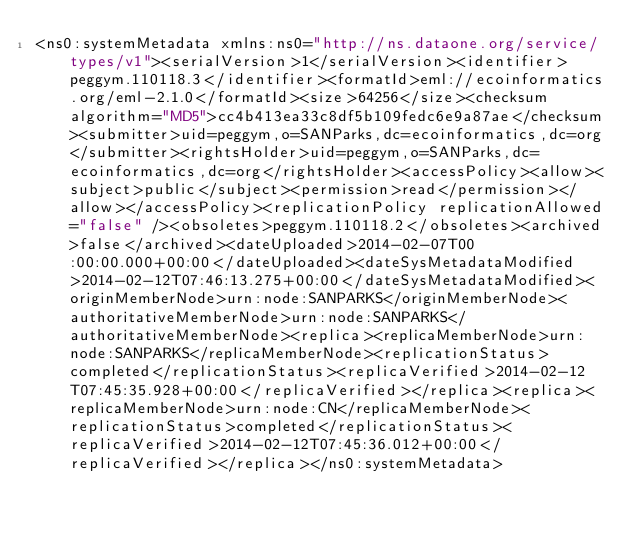<code> <loc_0><loc_0><loc_500><loc_500><_XML_><ns0:systemMetadata xmlns:ns0="http://ns.dataone.org/service/types/v1"><serialVersion>1</serialVersion><identifier>peggym.110118.3</identifier><formatId>eml://ecoinformatics.org/eml-2.1.0</formatId><size>64256</size><checksum algorithm="MD5">cc4b413ea33c8df5b109fedc6e9a87ae</checksum><submitter>uid=peggym,o=SANParks,dc=ecoinformatics,dc=org</submitter><rightsHolder>uid=peggym,o=SANParks,dc=ecoinformatics,dc=org</rightsHolder><accessPolicy><allow><subject>public</subject><permission>read</permission></allow></accessPolicy><replicationPolicy replicationAllowed="false" /><obsoletes>peggym.110118.2</obsoletes><archived>false</archived><dateUploaded>2014-02-07T00:00:00.000+00:00</dateUploaded><dateSysMetadataModified>2014-02-12T07:46:13.275+00:00</dateSysMetadataModified><originMemberNode>urn:node:SANPARKS</originMemberNode><authoritativeMemberNode>urn:node:SANPARKS</authoritativeMemberNode><replica><replicaMemberNode>urn:node:SANPARKS</replicaMemberNode><replicationStatus>completed</replicationStatus><replicaVerified>2014-02-12T07:45:35.928+00:00</replicaVerified></replica><replica><replicaMemberNode>urn:node:CN</replicaMemberNode><replicationStatus>completed</replicationStatus><replicaVerified>2014-02-12T07:45:36.012+00:00</replicaVerified></replica></ns0:systemMetadata></code> 